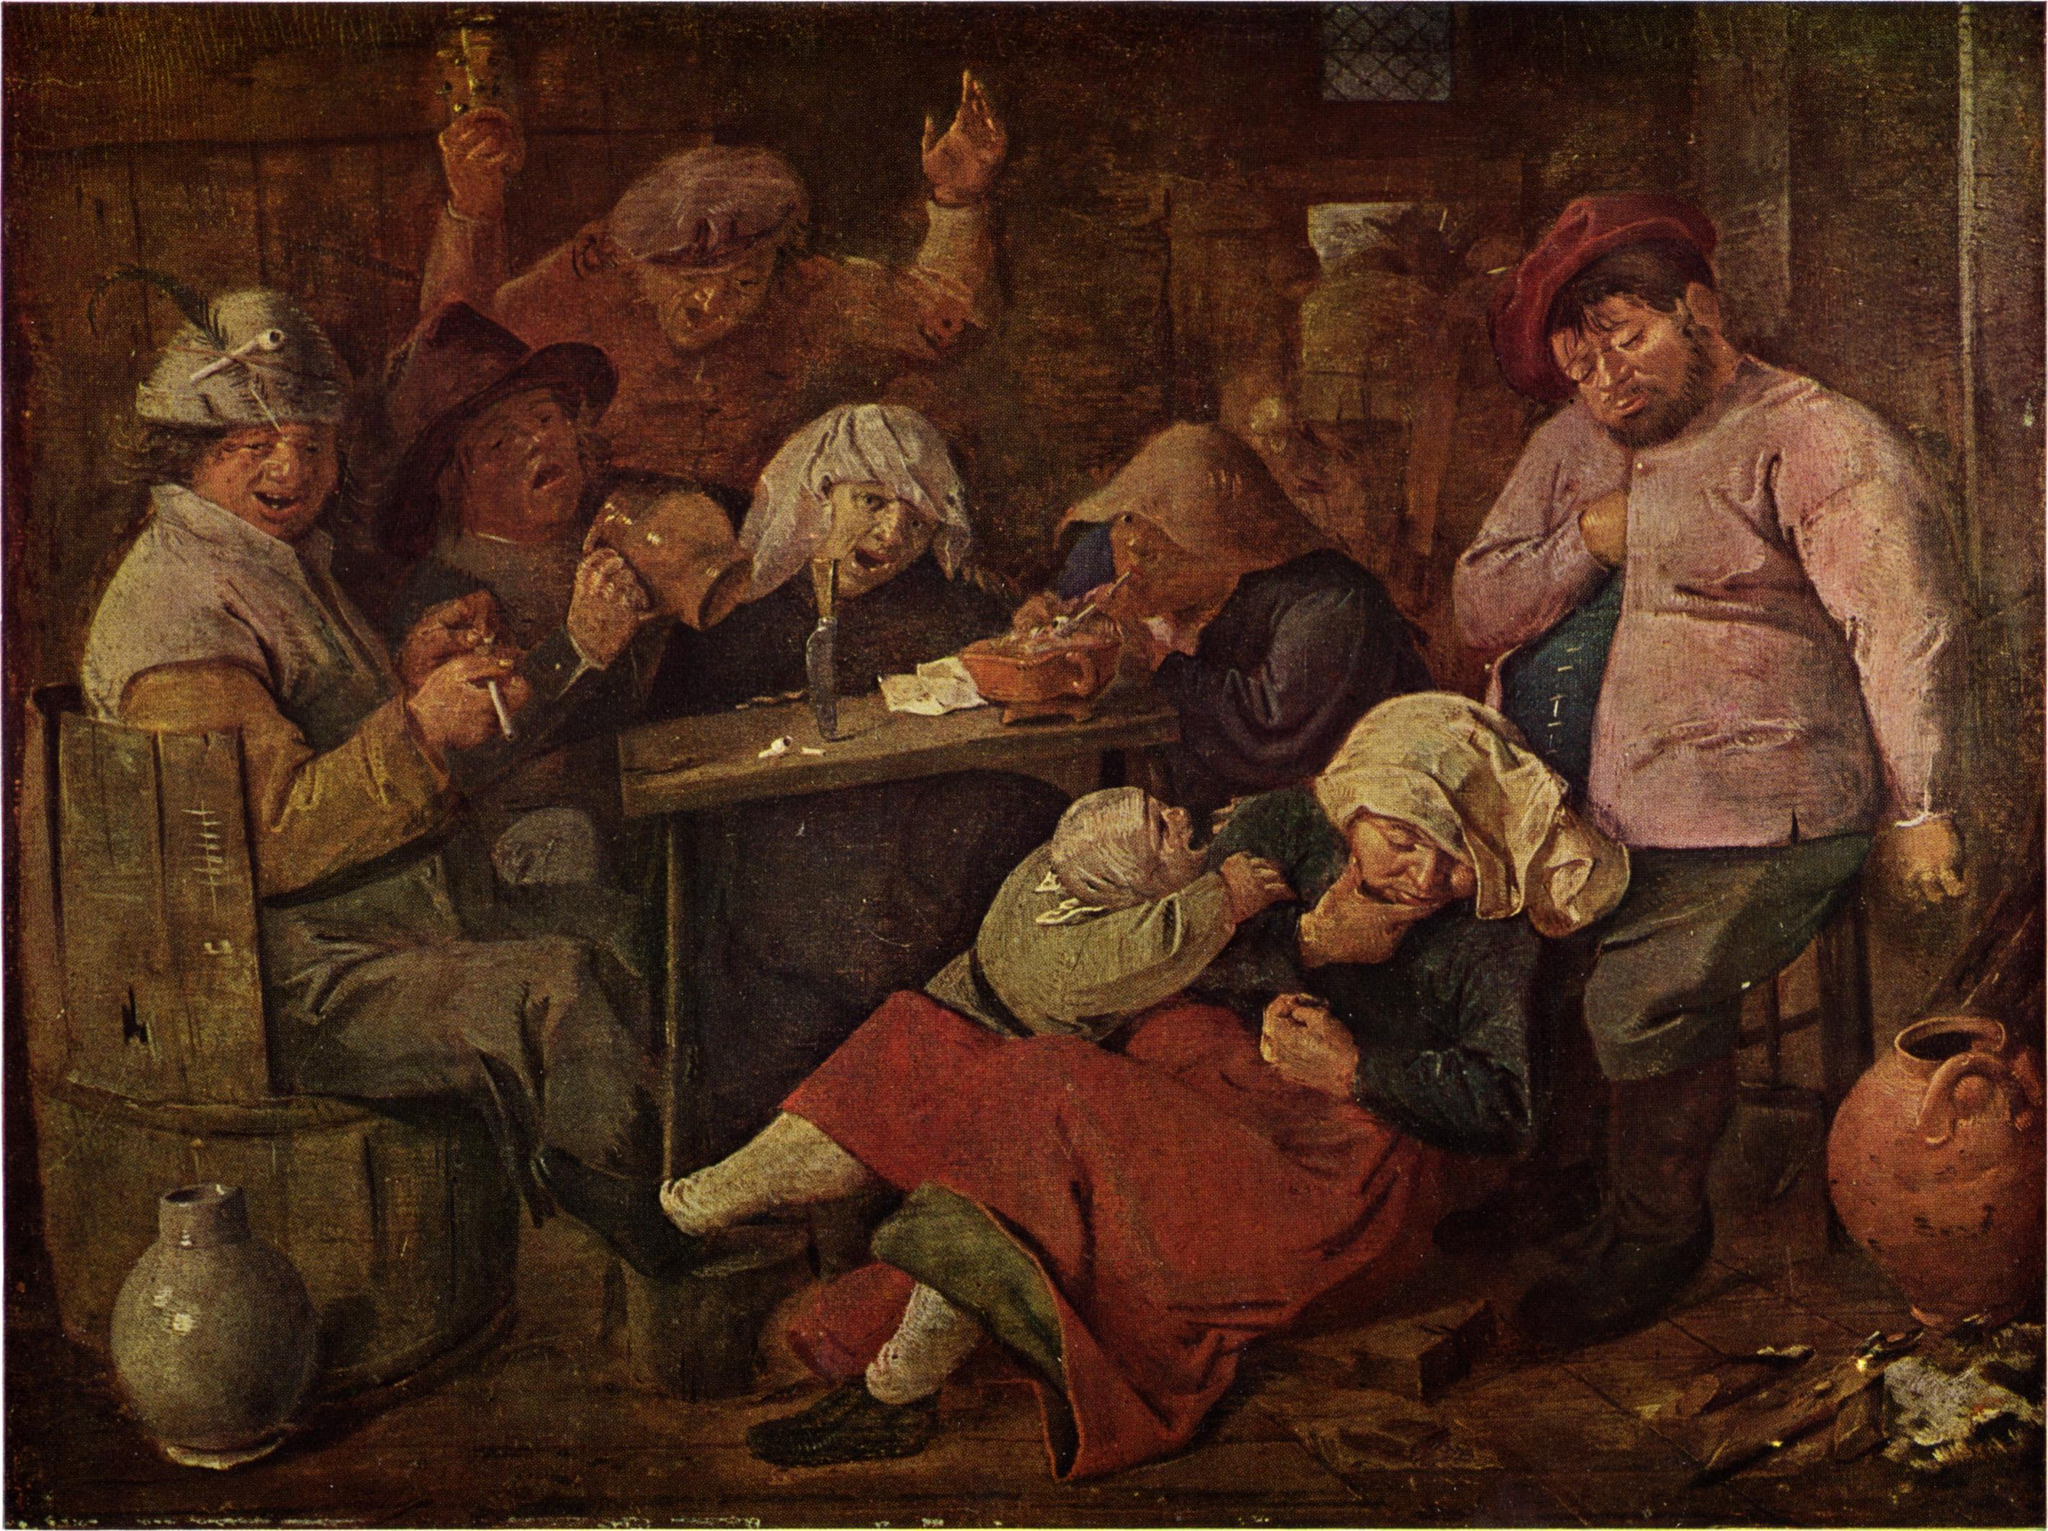Can you describe the emotions of the people depicted in this painting? The individuals in the painting display a mix of emotions that add to the lively atmosphere of the scene. Some appear jovial and animated, likely enjoying their drinks and the company of friends, while others seem more absorbed in the activities around them. The expression of the woman nursing the child suggests a sense of weariness, perhaps a moment of respite amidst the revelry. The man on the right, with his hand over his heart, might be lost in thought or experiencing a moment of introspection. Overall, the scene captures a vibrant, multifaceted portrayal of human emotion, making it both engaging and relatable. 